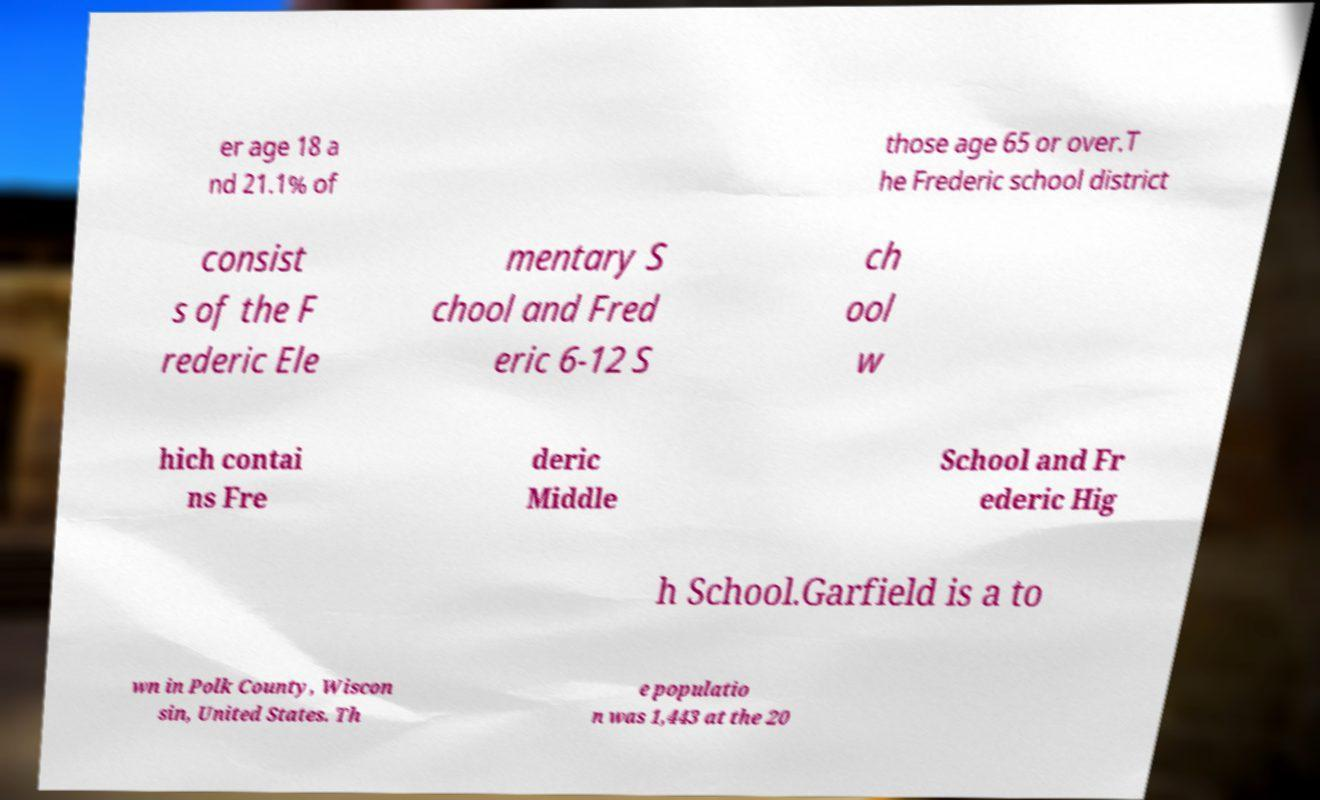Could you assist in decoding the text presented in this image and type it out clearly? er age 18 a nd 21.1% of those age 65 or over.T he Frederic school district consist s of the F rederic Ele mentary S chool and Fred eric 6-12 S ch ool w hich contai ns Fre deric Middle School and Fr ederic Hig h School.Garfield is a to wn in Polk County, Wiscon sin, United States. Th e populatio n was 1,443 at the 20 